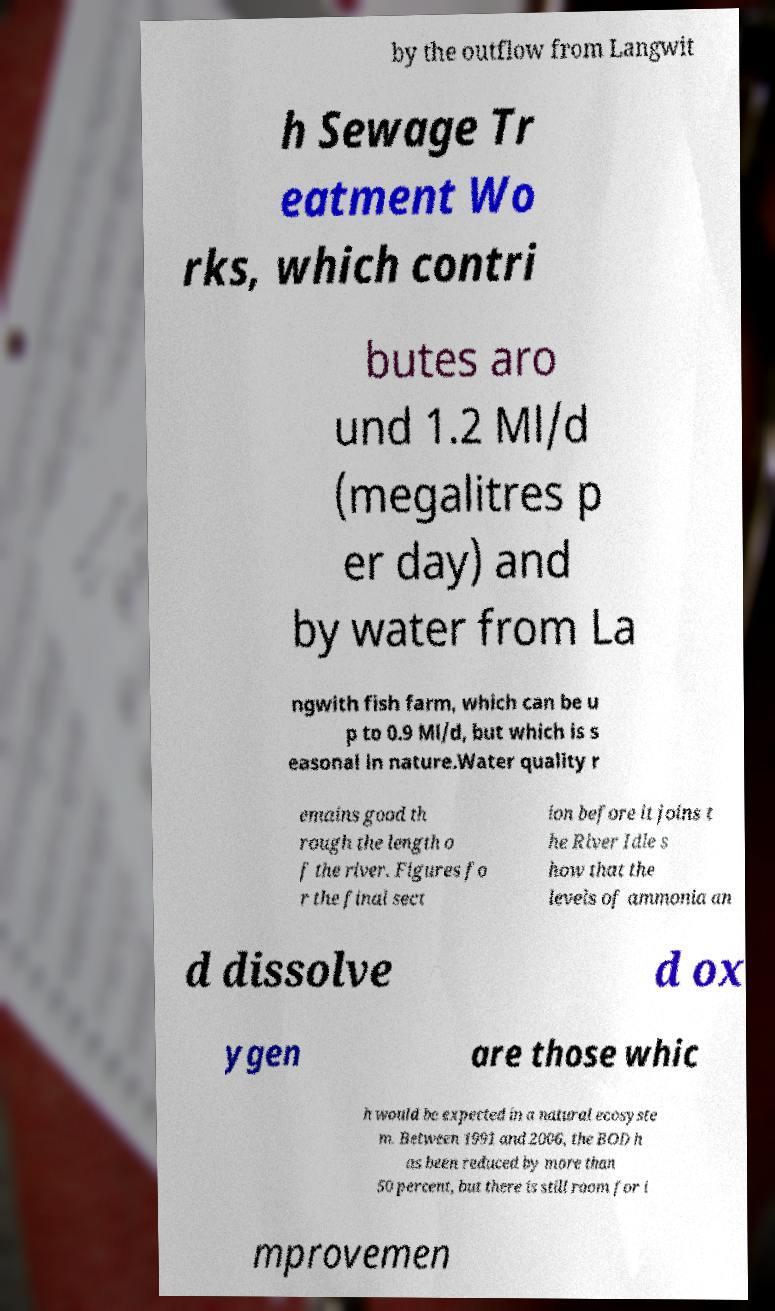For documentation purposes, I need the text within this image transcribed. Could you provide that? by the outflow from Langwit h Sewage Tr eatment Wo rks, which contri butes aro und 1.2 Ml/d (megalitres p er day) and by water from La ngwith fish farm, which can be u p to 0.9 Ml/d, but which is s easonal in nature.Water quality r emains good th rough the length o f the river. Figures fo r the final sect ion before it joins t he River Idle s how that the levels of ammonia an d dissolve d ox ygen are those whic h would be expected in a natural ecosyste m. Between 1991 and 2006, the BOD h as been reduced by more than 50 percent, but there is still room for i mprovemen 